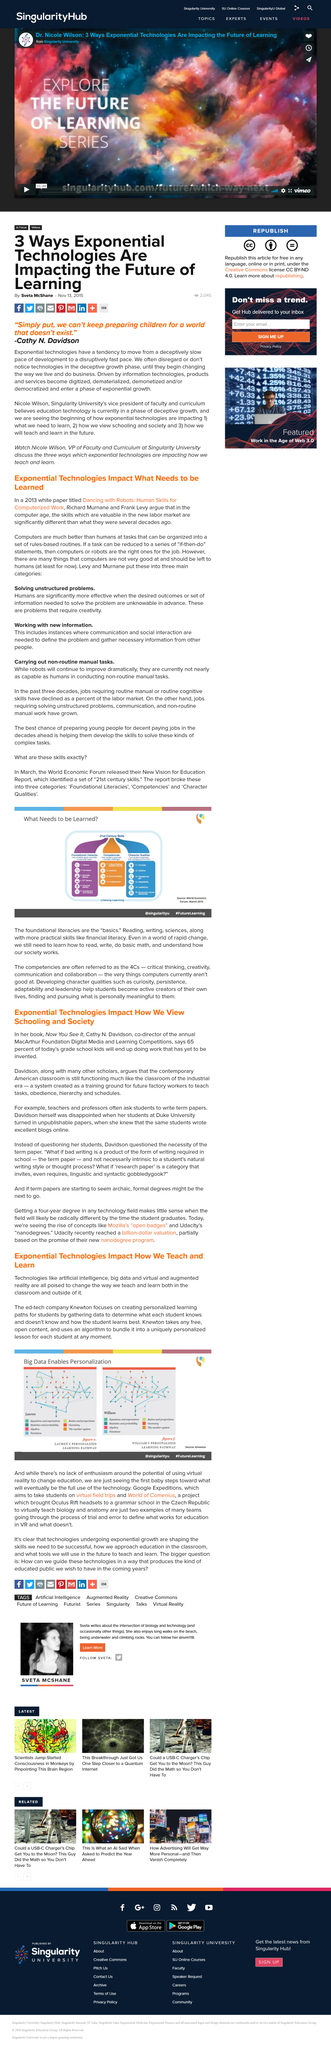Identify some key points in this picture. Lauren's Personalized Learning Pathway is the capture for figure E. WILLIAM'S PERSONALIZED LEARNING PATHWAY is the caption for figure f. Robots are currently not as capable at performing non-routine manual tasks as they are at routine manual tasks. In the book, Davidson questioned the necessity of the task mentioned in the text. Exponential technologies have a significant impact on how we teach and learn. 